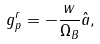Convert formula to latex. <formula><loc_0><loc_0><loc_500><loc_500>g _ { p } ^ { r } = - \frac { w } { \Omega _ { B } } { \hat { a } } ,</formula> 